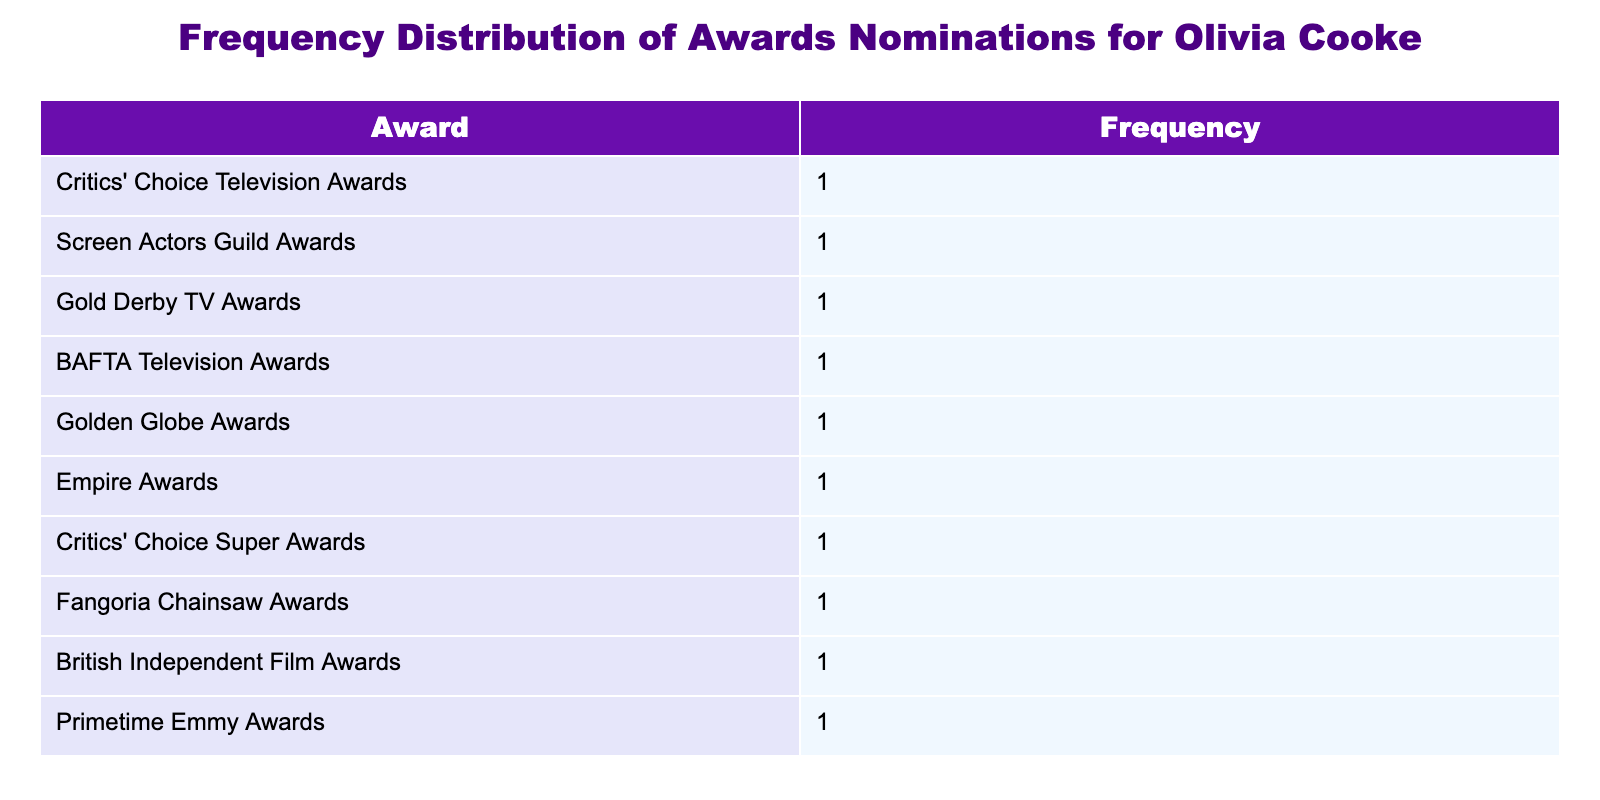What was Olivia Cooke's total number of award nominations? Each row in the table represents a single nomination for a different award. Since there are 10 rows in the table, we can sum the number of nominations, which is 1 for each award, leading to a total of 10 nominations.
Answer: 10 Which awards did Olivia Cooke receive nominations from in 2018? In the year 2018, the table lists two awards: the Gold Derby TV Awards and the BAFTA Television Awards, each with 1 nomination.
Answer: Gold Derby TV Awards, BAFTA Television Awards Is there any award listed where Olivia Cooke has received more than one nomination? By reviewing each row of the table, I can see that every listed award has only one nomination (frequency of 1), thus confirming that there is no award with more than one nomination.
Answer: No What year did Olivia Cooke receive nominations for the Golden Globe Awards? The table explicitly states that the Golden Globe Awards nominations occurred in the year 2020, and it shows 1 nomination for that year.
Answer: 2020 What is the frequency of nominations for the British Independent Film Awards? Examining the table, I can find that there is exactly 1 nomination for the British Independent Film Awards listed under the year 2022.
Answer: 1 How many years did Olivia Cooke receive award nominations in total? A quick count of the unique years listed in the table shows multiple entries for different awards over 10 distinct years, specifically: 2016, 2017, 2018, 2020, 2021, 2022, and 2023, giving us a total of 8 years.
Answer: 8 In which year did Olivia Cooke receive her first award nomination? The first year listed in the table is 2016, which corresponds to her nomination at the Critics' Choice Television Awards.
Answer: 2016 If we were to arrange the awards by the frequency of nominations, which award would be at the top? Since each award in the table has a frequency of 1, they are all equal. Therefore, there is no single award that can be deemed as being "at the top," as they are all tied.
Answer: None (All ties) 